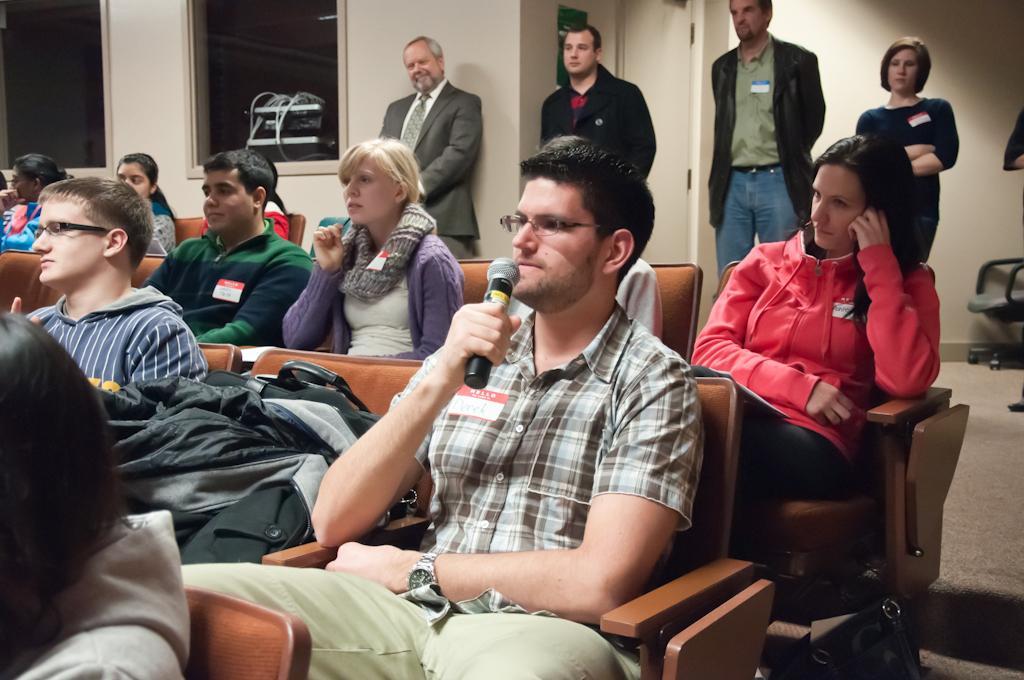In one or two sentences, can you explain what this image depicts? I can see a group of people are sitting on the chairs among them this man is holding a microphone in the hand. In the background some people are standing on the floor. I can also see white color wall, a chair and other objects. 